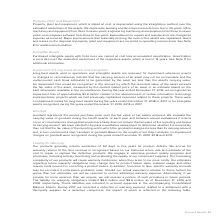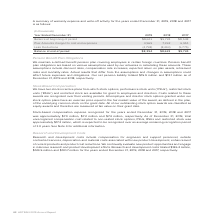According to Adtran's financial document, What was the liability for warranty obligations in 2019? According to the financial document, $8.4 million. The relevant text states: "ds. The liability for warranty obligations totaled $8.4 million and $8.6 million as of December 31, 2019 and 2018, respectively. These liabilities are included in a..." Also, What was the balance at beginning of period in 2019? According to the financial document, $8,623 (in thousands). The relevant text states: "Balance at beginning of period $8,623 $9,724 $8,548..." Also, What was the  Balance at end of period in 2017? According to the financial document, $9,724 (in thousands). The relevant text states: "Balance at beginning of period $8,623 $9,724 $8,548..." Also, can you calculate: What was the change in the balance at the beginning of period between 2018 and 2019? Based on the calculation: $8,623-$9,724, the result is -1101 (in thousands). This is based on the information: "Balance at beginning of period $8,623 $9,724 $8,548 Balance at beginning of period $8,623 $9,724 $8,548..." The key data points involved are: 8,623, 9,724. Also, can you calculate: What was the change in the balance at the end of period between 2018 and 2019? Based on the calculation: $8,394-$8,623, the result is -229 (in thousands). This is based on the information: "Balance at end of period $8,394 $8,623 $9,724 Balance at end of period $8,394 $8,623 $9,724..." The key data points involved are: 8,394, 8,623. Also, can you calculate: What was the percentage change in amounts charged to cost and expenses between 2017 and 2018? To answer this question, I need to perform calculations using the financial data. The calculation is: (7,392-6,951)/6,951, which equals 6.34 (percentage). This is based on the information: "Amounts charged to cost and expenses 4,569 7,392 6,951 Plus: Amounts charged to cost and expenses 4,569 7,392 6,951..." The key data points involved are: 6,951, 7,392. 